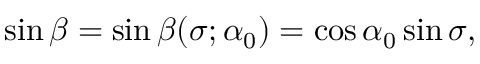<formula> <loc_0><loc_0><loc_500><loc_500>\sin \beta = \sin \beta ( \sigma ; \alpha _ { 0 } ) = \cos \alpha _ { 0 } \sin \sigma ,</formula> 